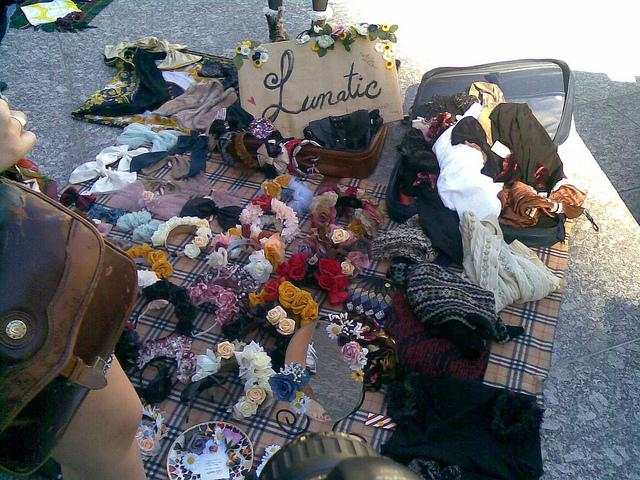Which type flower is most oft repeated here?

Choices:
A) gladiola
B) daisy
C) rose
D) iris rose 